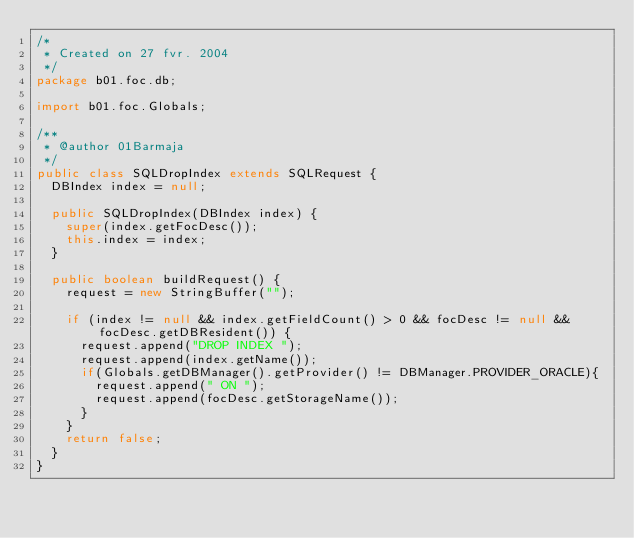Convert code to text. <code><loc_0><loc_0><loc_500><loc_500><_Java_>/*
 * Created on 27 fvr. 2004
 */
package b01.foc.db;

import b01.foc.Globals;

/**
 * @author 01Barmaja
 */
public class SQLDropIndex extends SQLRequest {
  DBIndex index = null;
  
  public SQLDropIndex(DBIndex index) {
    super(index.getFocDesc());
    this.index = index;
  }

  public boolean buildRequest() {
    request = new StringBuffer("");

    if (index != null && index.getFieldCount() > 0 && focDesc != null && focDesc.getDBResident()) {
      request.append("DROP INDEX ");
      request.append(index.getName());
      if(Globals.getDBManager().getProvider() != DBManager.PROVIDER_ORACLE){
        request.append(" ON ");
        request.append(focDesc.getStorageName());
      }
    }
    return false;
  }
}
</code> 